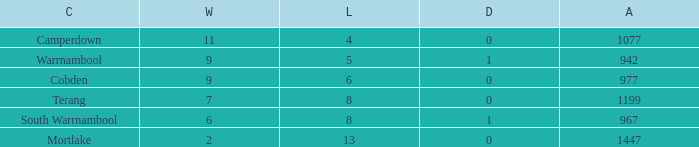What is the draw when the losses were more than 8 and less than 2 wins? None. 